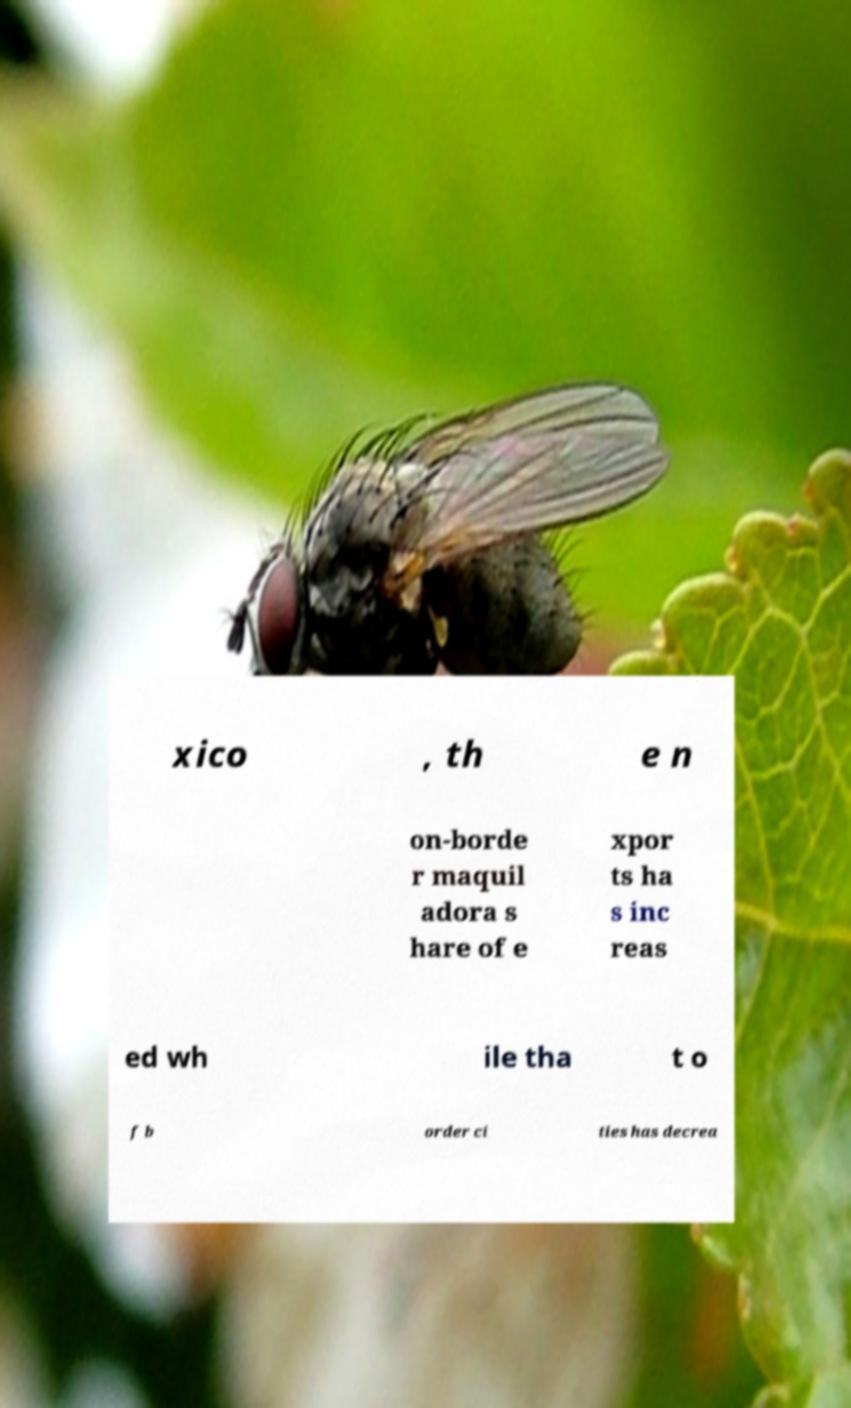There's text embedded in this image that I need extracted. Can you transcribe it verbatim? xico , th e n on-borde r maquil adora s hare of e xpor ts ha s inc reas ed wh ile tha t o f b order ci ties has decrea 